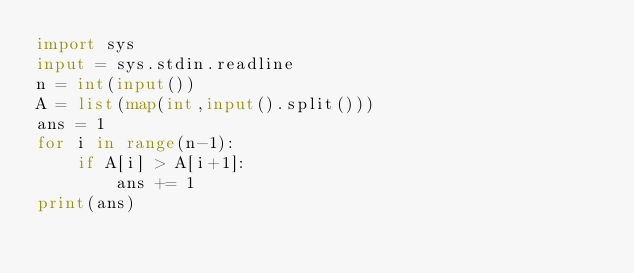Convert code to text. <code><loc_0><loc_0><loc_500><loc_500><_Python_>import sys
input = sys.stdin.readline
n = int(input())
A = list(map(int,input().split()))
ans = 1
for i in range(n-1):
    if A[i] > A[i+1]:
        ans += 1
print(ans)</code> 